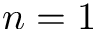Convert formula to latex. <formula><loc_0><loc_0><loc_500><loc_500>n = 1</formula> 